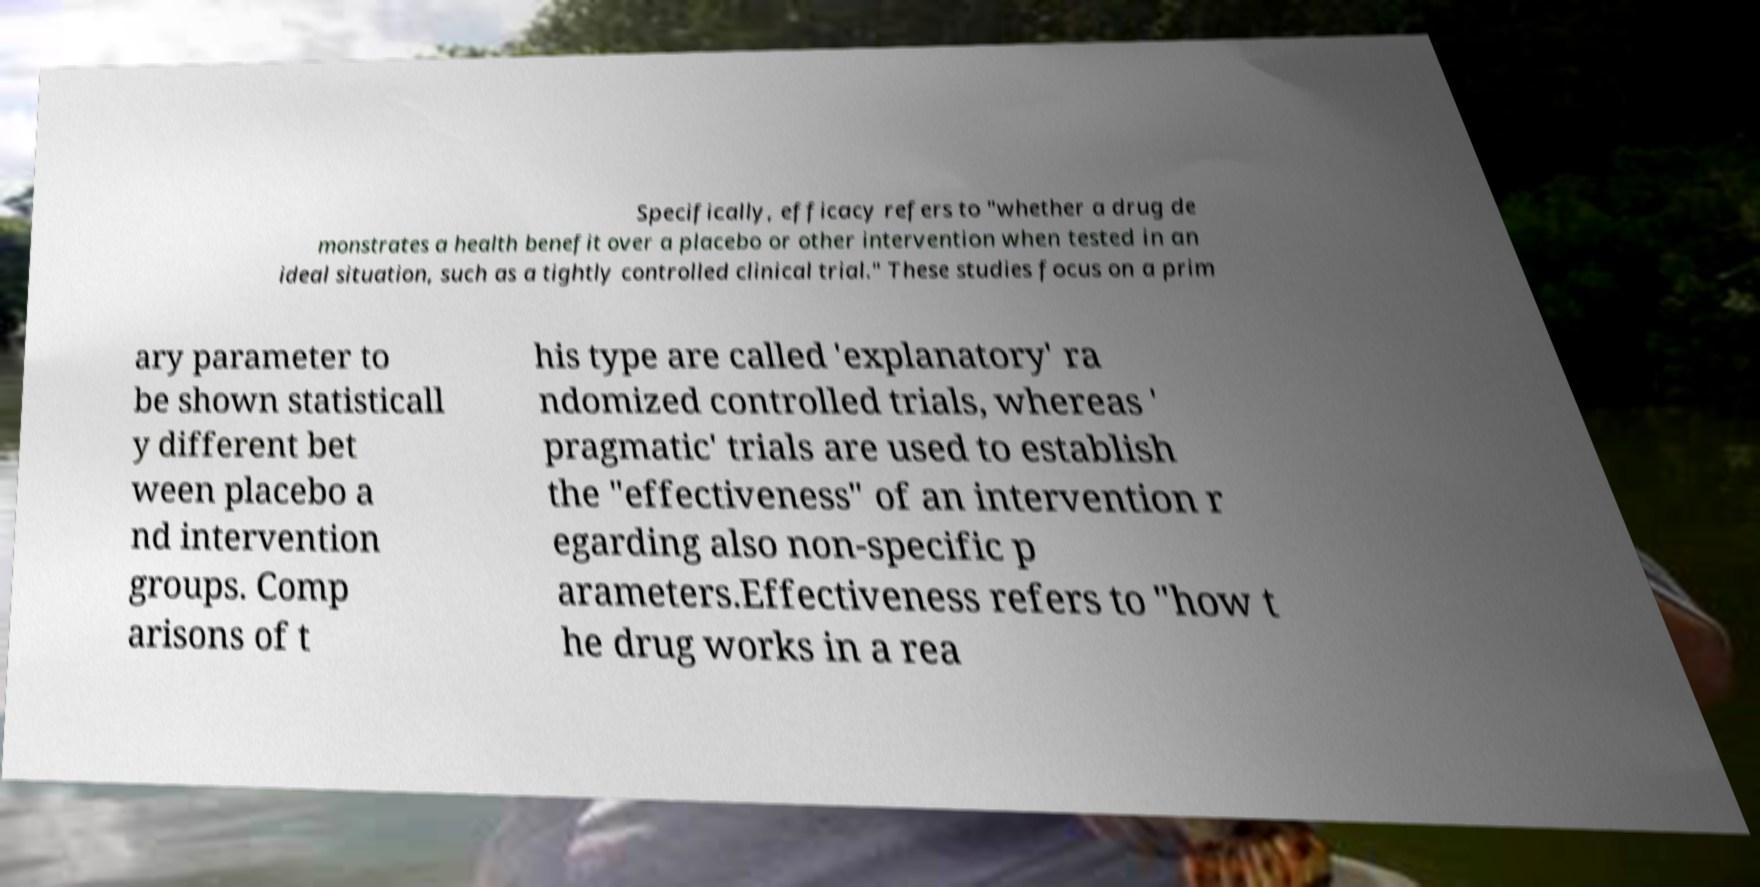Could you assist in decoding the text presented in this image and type it out clearly? Specifically, efficacy refers to "whether a drug de monstrates a health benefit over a placebo or other intervention when tested in an ideal situation, such as a tightly controlled clinical trial." These studies focus on a prim ary parameter to be shown statisticall y different bet ween placebo a nd intervention groups. Comp arisons of t his type are called 'explanatory' ra ndomized controlled trials, whereas ' pragmatic' trials are used to establish the "effectiveness" of an intervention r egarding also non-specific p arameters.Effectiveness refers to "how t he drug works in a rea 